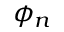<formula> <loc_0><loc_0><loc_500><loc_500>\phi _ { n }</formula> 